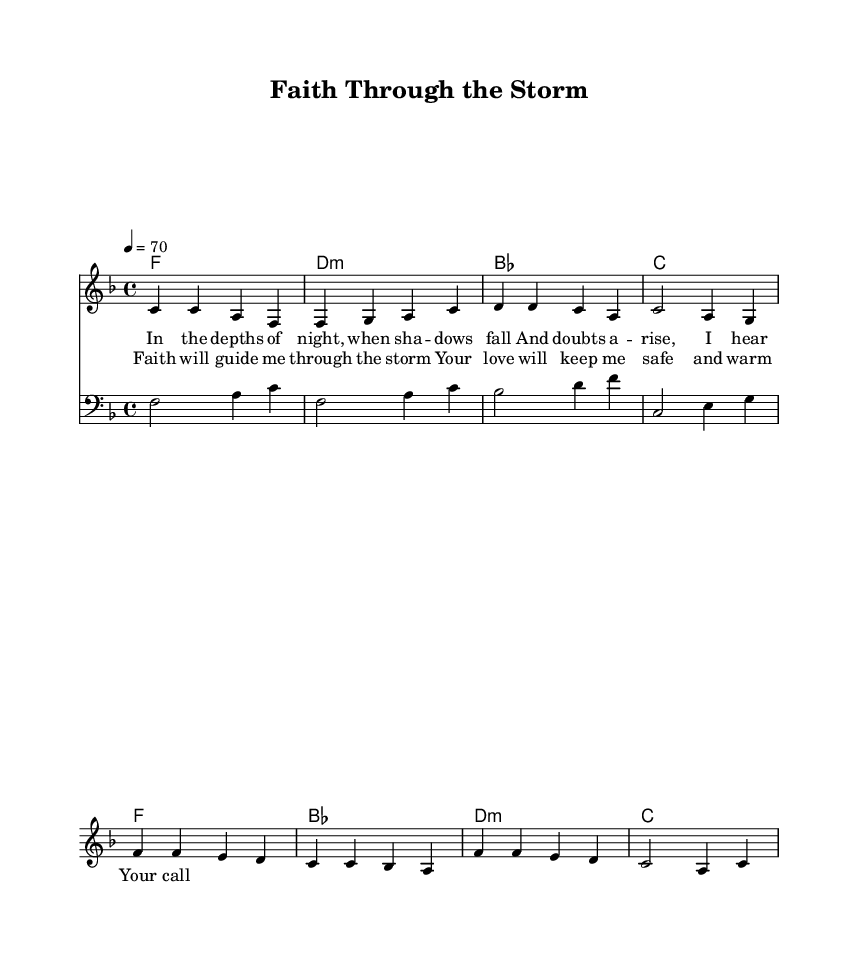What is the key signature of this music? The key signature is indicated by the presence of one flat, which corresponds to F major.
Answer: F major What is the time signature of the piece? The time signature is found at the beginning of the sheet music, represented by the fraction 4 over 4, indicating four beats in each measure.
Answer: 4/4 What is the tempo marking of this music? The tempo marking is specified as 4 equals 70, which refers to the beats per minute.
Answer: 70 How many bars are in the verse section? The verse section is contained within four measures, which can be counted from the melody line.
Answer: 4 What is the primary theme expressed in the lyrics of the chorus? The chorus lyrics emphasize a message of faith and divine protection during difficult times, indicating a reliance on spiritual support.
Answer: Faith and protection What type of chord is primarily used in the verse? The verse prominently features a mix of F major and D minor chords, which are characteristic of soulful funk ballads.
Answer: F major and D minor How does the bass line complement the melody in terms of rhythm? The bass line plays longer notes (half notes) that provide a solid foundation, allowing the melody to have a more rhythmic and flowing quality with its quarter notes.
Answer: Half notes and quarter notes 